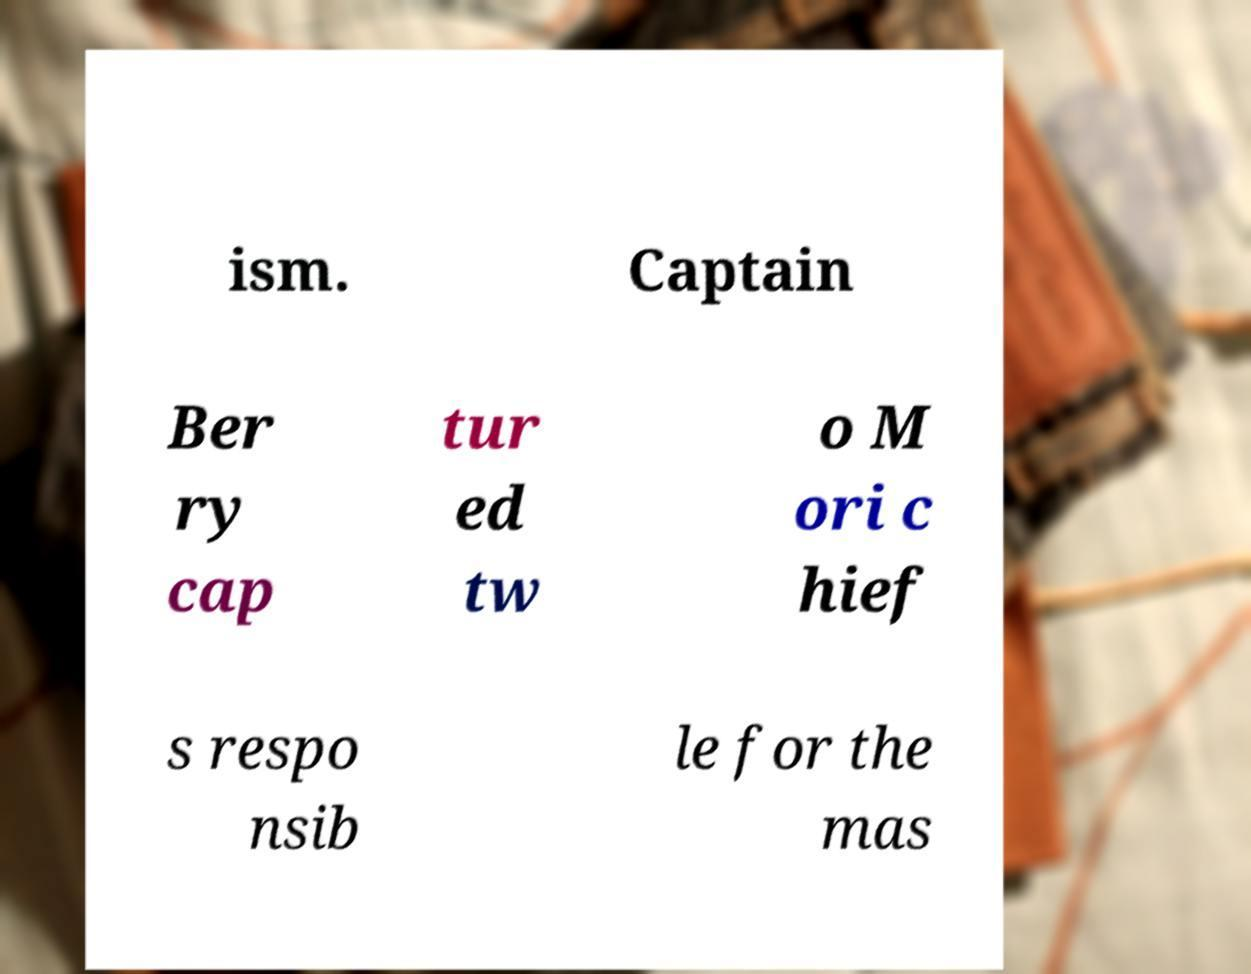Can you read and provide the text displayed in the image?This photo seems to have some interesting text. Can you extract and type it out for me? ism. Captain Ber ry cap tur ed tw o M ori c hief s respo nsib le for the mas 